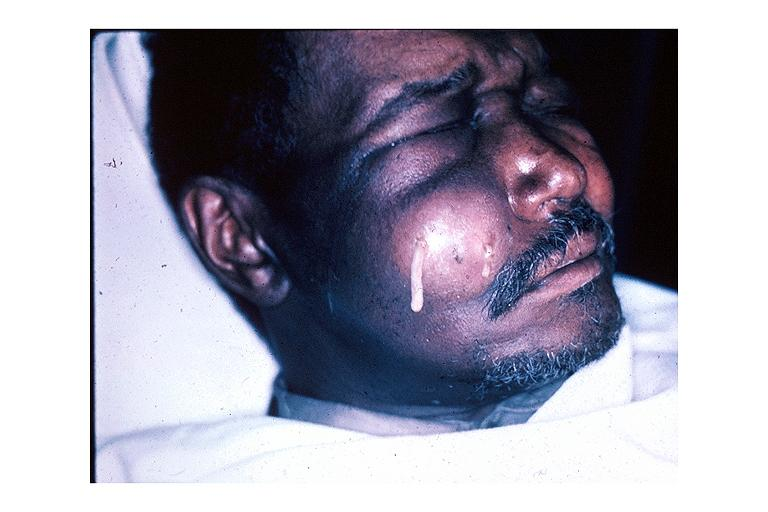s oral present?
Answer the question using a single word or phrase. Yes 